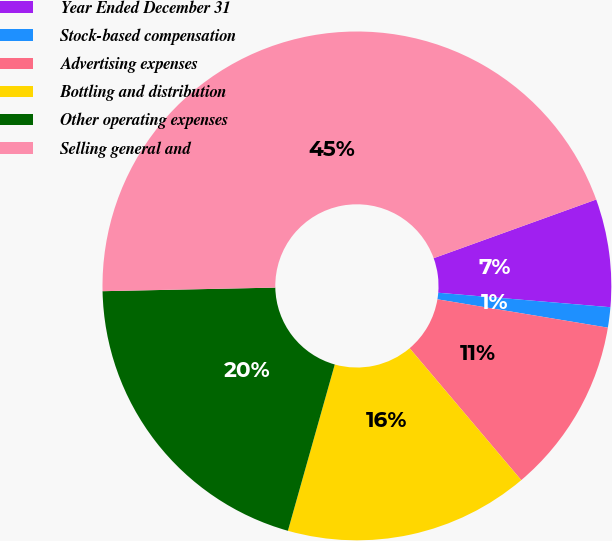Convert chart to OTSL. <chart><loc_0><loc_0><loc_500><loc_500><pie_chart><fcel>Year Ended December 31<fcel>Stock-based compensation<fcel>Advertising expenses<fcel>Bottling and distribution<fcel>Other operating expenses<fcel>Selling general and<nl><fcel>6.85%<fcel>1.29%<fcel>11.2%<fcel>15.55%<fcel>20.3%<fcel>44.82%<nl></chart> 